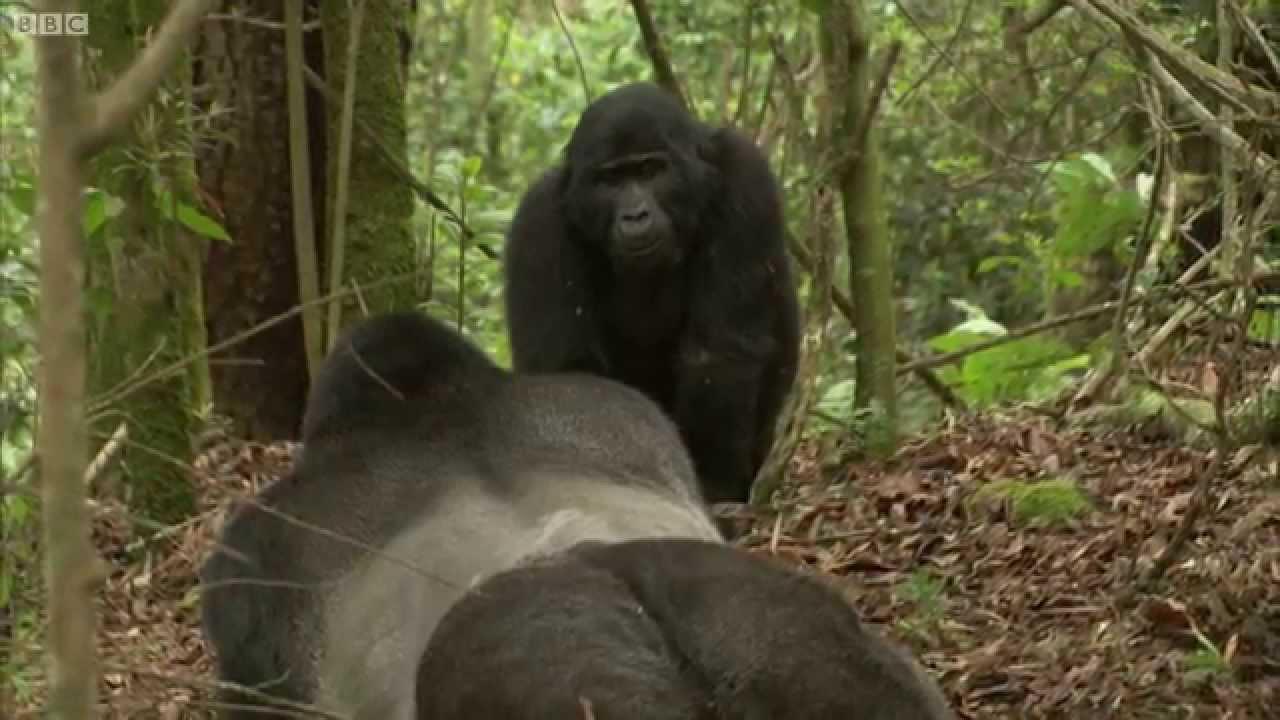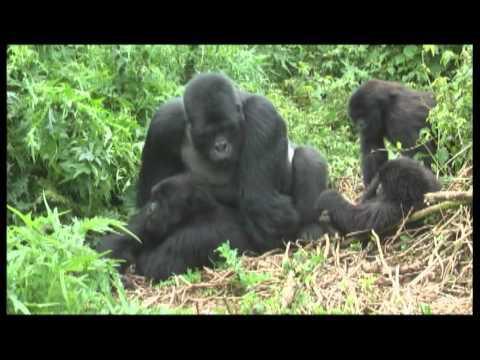The first image is the image on the left, the second image is the image on the right. For the images displayed, is the sentence "At least one image shows upright gorillas engaged in a confrontation, with at least one gorilla's back turned to the camera and one gorilla with fangs bared." factually correct? Answer yes or no. No. The first image is the image on the left, the second image is the image on the right. Evaluate the accuracy of this statement regarding the images: "The gorillas are fighting.". Is it true? Answer yes or no. No. 